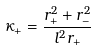Convert formula to latex. <formula><loc_0><loc_0><loc_500><loc_500>\kappa _ { + } = \frac { r _ { + } ^ { 2 } + r _ { - } ^ { 2 } } { l ^ { 2 } r _ { + } }</formula> 